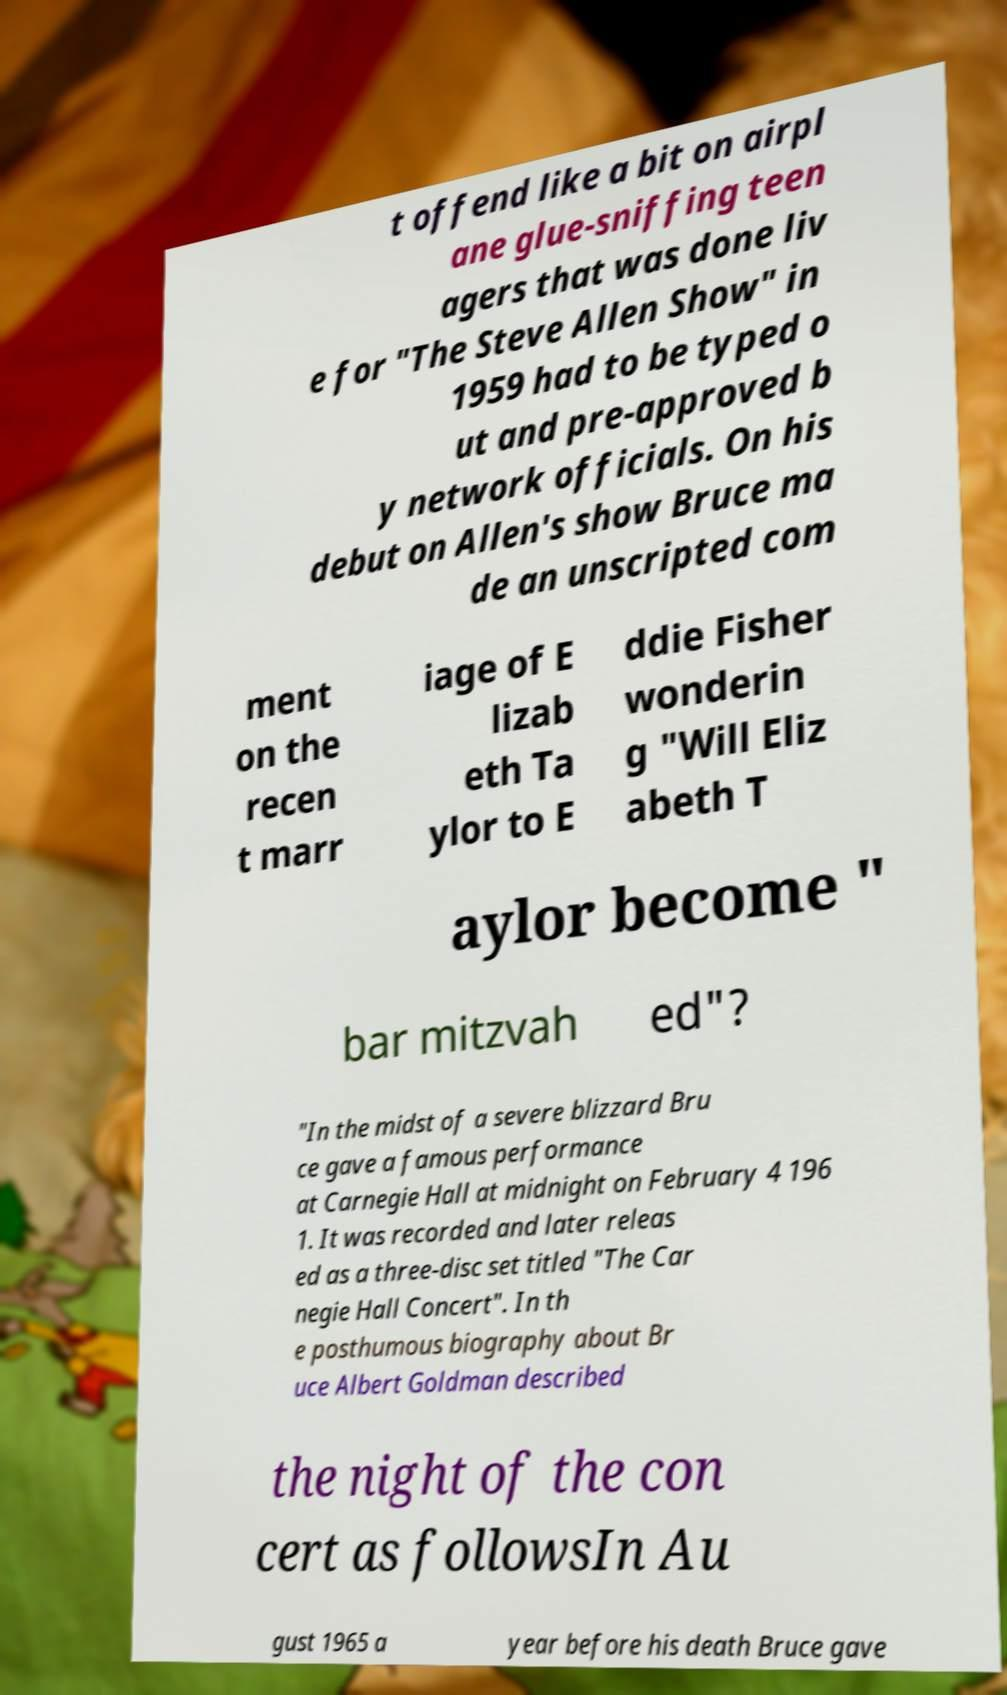Could you assist in decoding the text presented in this image and type it out clearly? t offend like a bit on airpl ane glue-sniffing teen agers that was done liv e for "The Steve Allen Show" in 1959 had to be typed o ut and pre-approved b y network officials. On his debut on Allen's show Bruce ma de an unscripted com ment on the recen t marr iage of E lizab eth Ta ylor to E ddie Fisher wonderin g "Will Eliz abeth T aylor become " bar mitzvah ed"? "In the midst of a severe blizzard Bru ce gave a famous performance at Carnegie Hall at midnight on February 4 196 1. It was recorded and later releas ed as a three-disc set titled "The Car negie Hall Concert". In th e posthumous biography about Br uce Albert Goldman described the night of the con cert as followsIn Au gust 1965 a year before his death Bruce gave 